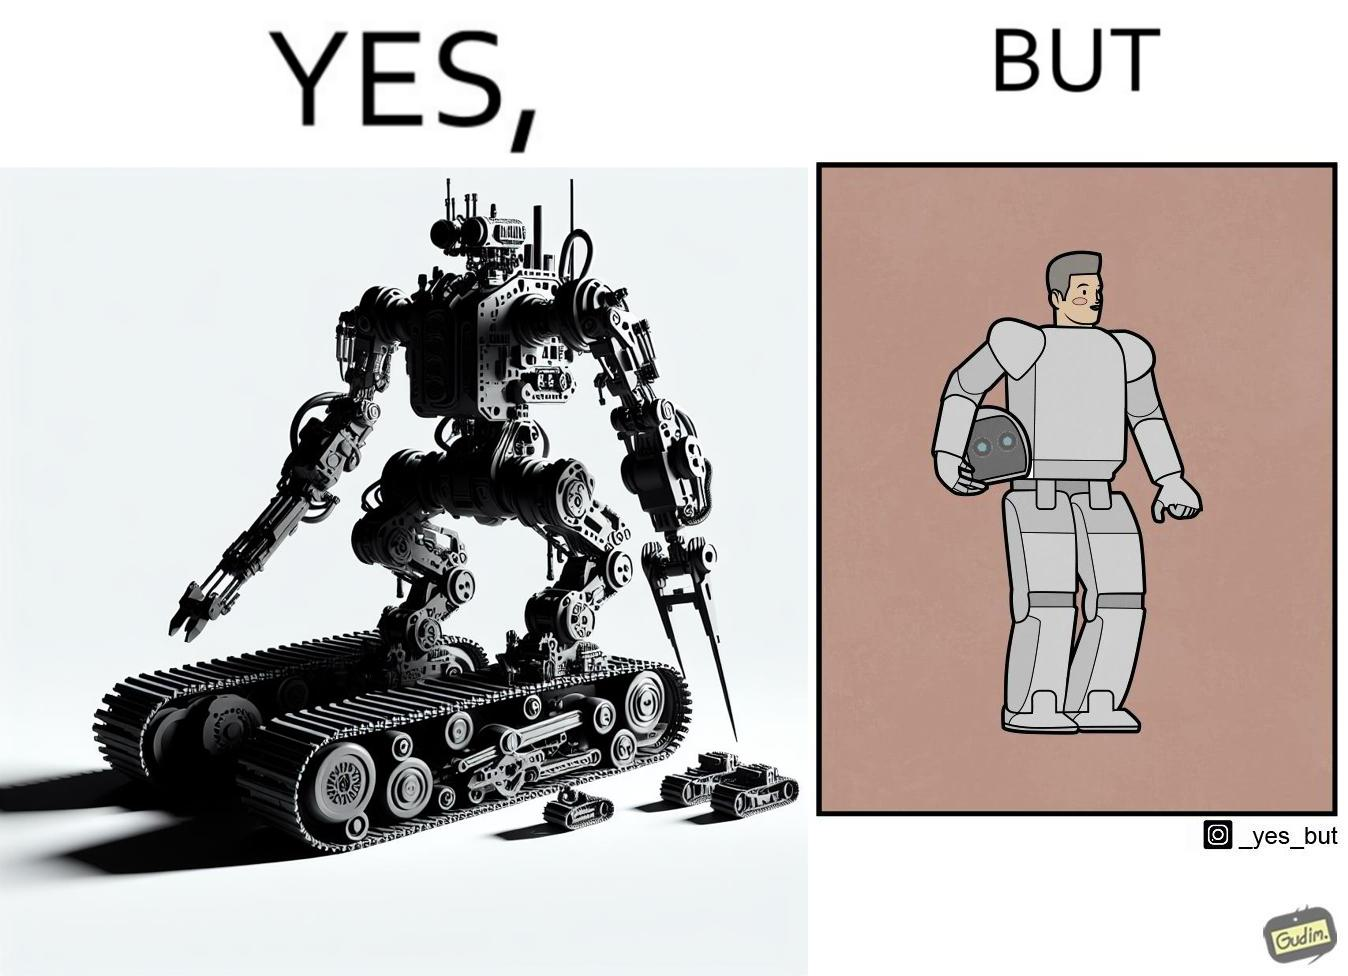Compare the left and right sides of this image. In the left part of the image: It is a robot In the right part of the image: It is a human in a robot suit 